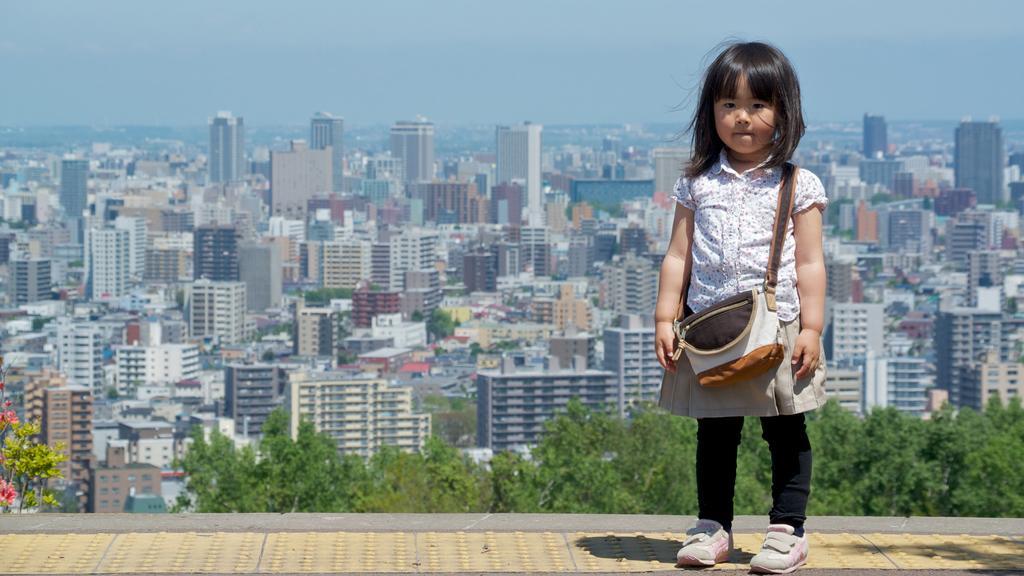Describe this image in one or two sentences. In this picture we can see a girl carrying a bag and standing on a path, flowers, trees, buildings and in the background we can see the sky. 